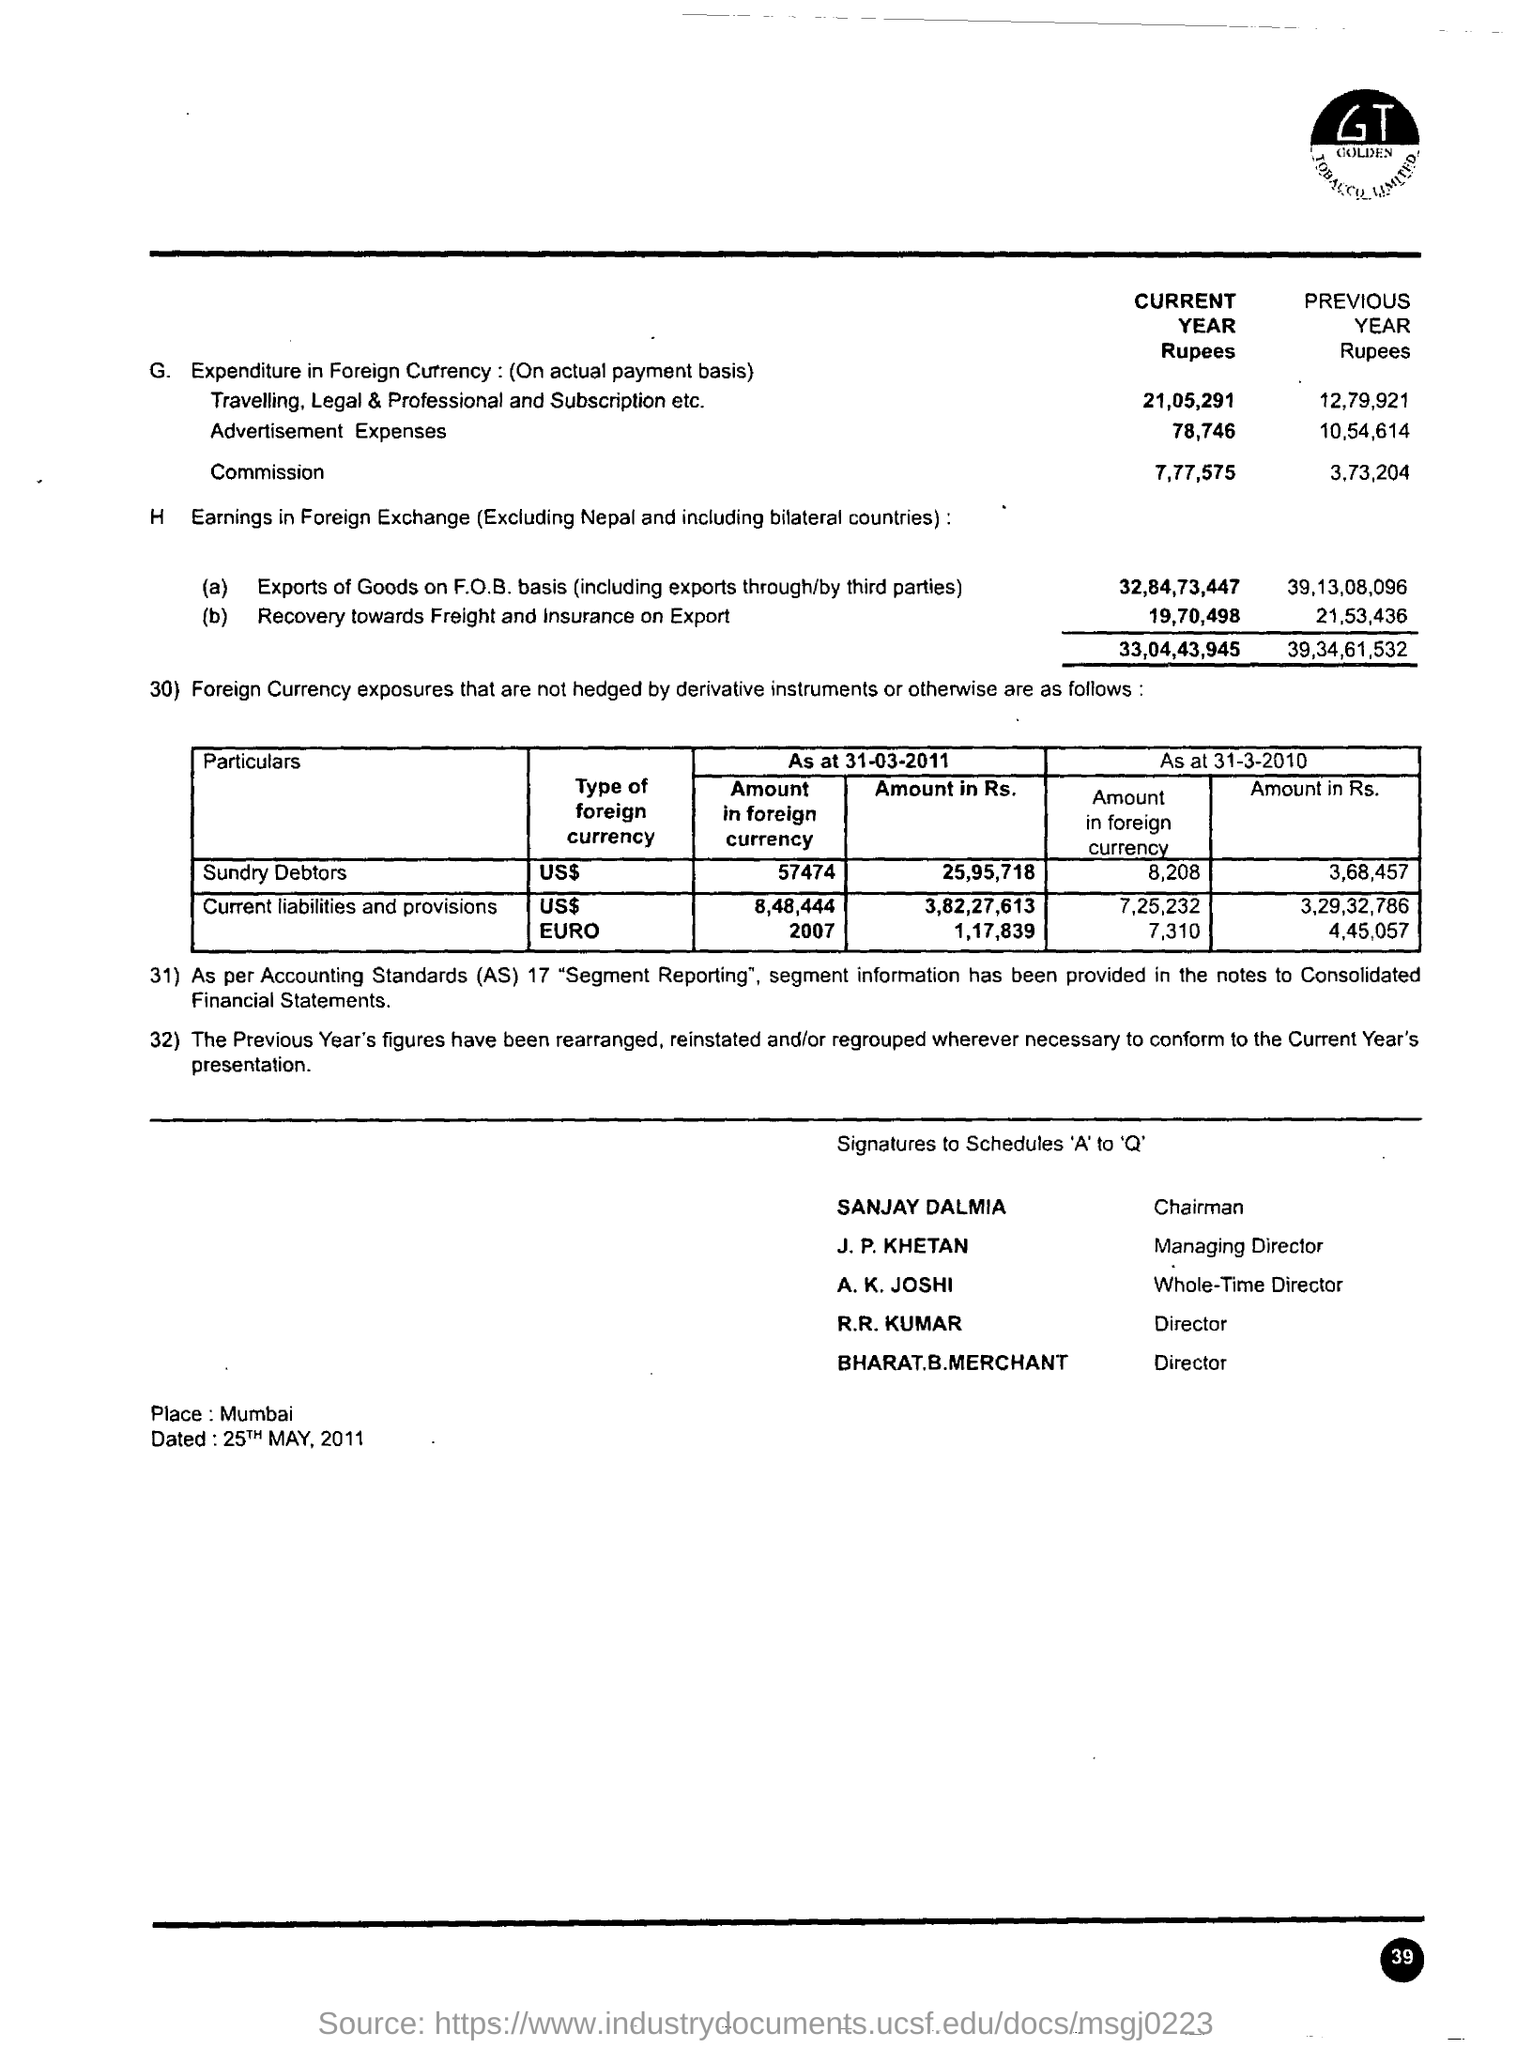What is the Commission for the current year in Rupees?
Ensure brevity in your answer.  7,77,575. When is the document dated?
Provide a succinct answer. 25TH MAY, 2011. Who is the Chairman?
Your response must be concise. Sanjay Dalmia. Which company's name is mentioned?
Offer a very short reply. Golden Tobacco Limited. 